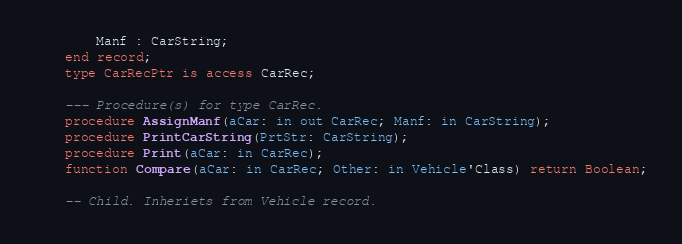Convert code to text. <code><loc_0><loc_0><loc_500><loc_500><_Ada_>        Manf : CarString;
    end record;
    type CarRecPtr is access CarRec;

    --- Procedure(s) for type CarRec.
    procedure AssignManf(aCar: in out CarRec; Manf: in CarString);
    procedure PrintCarString(PrtStr: CarString);
    procedure Print(aCar: in CarRec);
    function Compare(aCar: in CarRec; Other: in Vehicle'Class) return Boolean;

    -- Child. Inheriets from Vehicle record.</code> 